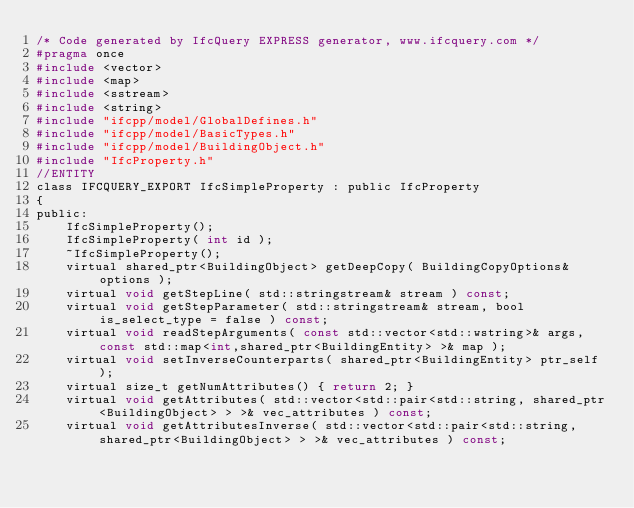Convert code to text. <code><loc_0><loc_0><loc_500><loc_500><_C_>/* Code generated by IfcQuery EXPRESS generator, www.ifcquery.com */
#pragma once
#include <vector>
#include <map>
#include <sstream>
#include <string>
#include "ifcpp/model/GlobalDefines.h"
#include "ifcpp/model/BasicTypes.h"
#include "ifcpp/model/BuildingObject.h"
#include "IfcProperty.h"
//ENTITY
class IFCQUERY_EXPORT IfcSimpleProperty : public IfcProperty
{ 
public:
	IfcSimpleProperty();
	IfcSimpleProperty( int id );
	~IfcSimpleProperty();
	virtual shared_ptr<BuildingObject> getDeepCopy( BuildingCopyOptions& options );
	virtual void getStepLine( std::stringstream& stream ) const;
	virtual void getStepParameter( std::stringstream& stream, bool is_select_type = false ) const;
	virtual void readStepArguments( const std::vector<std::wstring>& args, const std::map<int,shared_ptr<BuildingEntity> >& map );
	virtual void setInverseCounterparts( shared_ptr<BuildingEntity> ptr_self );
	virtual size_t getNumAttributes() { return 2; }
	virtual void getAttributes( std::vector<std::pair<std::string, shared_ptr<BuildingObject> > >& vec_attributes ) const;
	virtual void getAttributesInverse( std::vector<std::pair<std::string, shared_ptr<BuildingObject> > >& vec_attributes ) const;</code> 